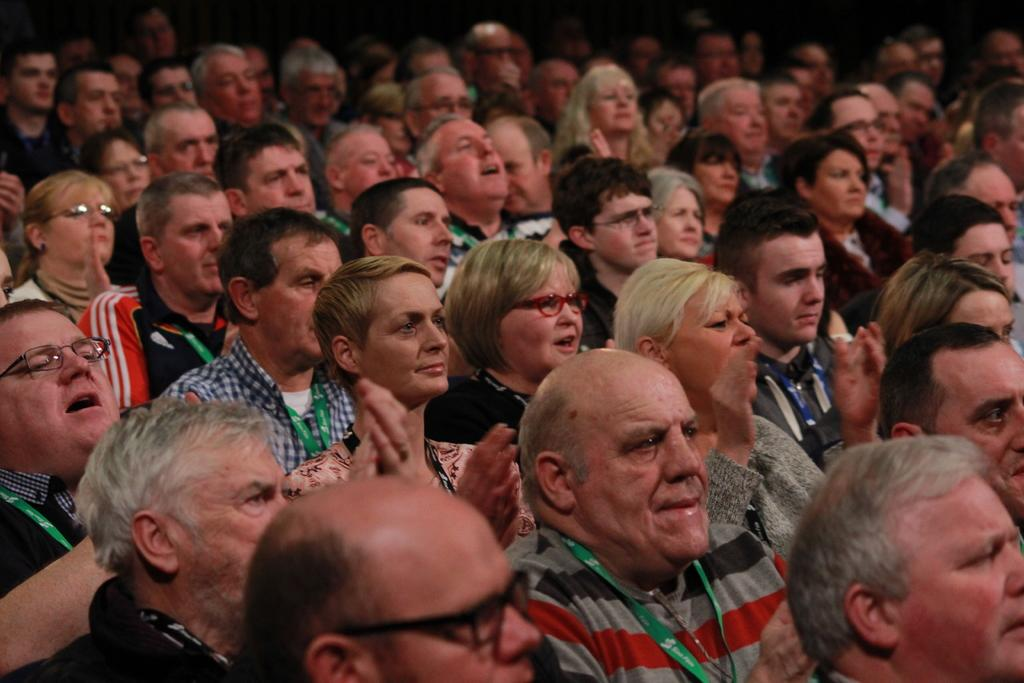Who or what can be seen in the image? There are people in the image. What are some of the people doing in the image? Some people are looking to the right side of the image, and some people are clapping. Are there any trees visible in the image? There is no mention of trees in the provided facts, so we cannot determine if any are present in the image. 